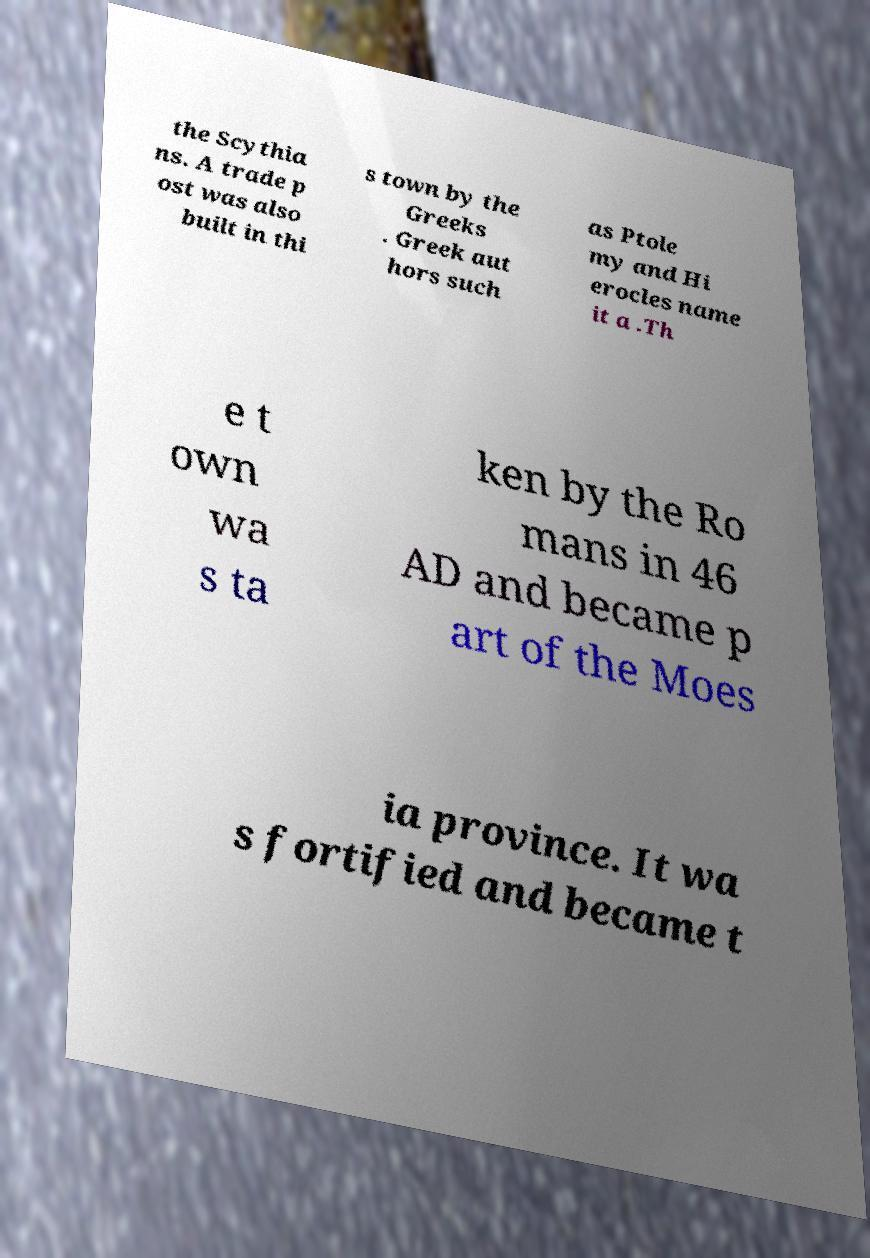Could you assist in decoding the text presented in this image and type it out clearly? the Scythia ns. A trade p ost was also built in thi s town by the Greeks . Greek aut hors such as Ptole my and Hi erocles name it a .Th e t own wa s ta ken by the Ro mans in 46 AD and became p art of the Moes ia province. It wa s fortified and became t 